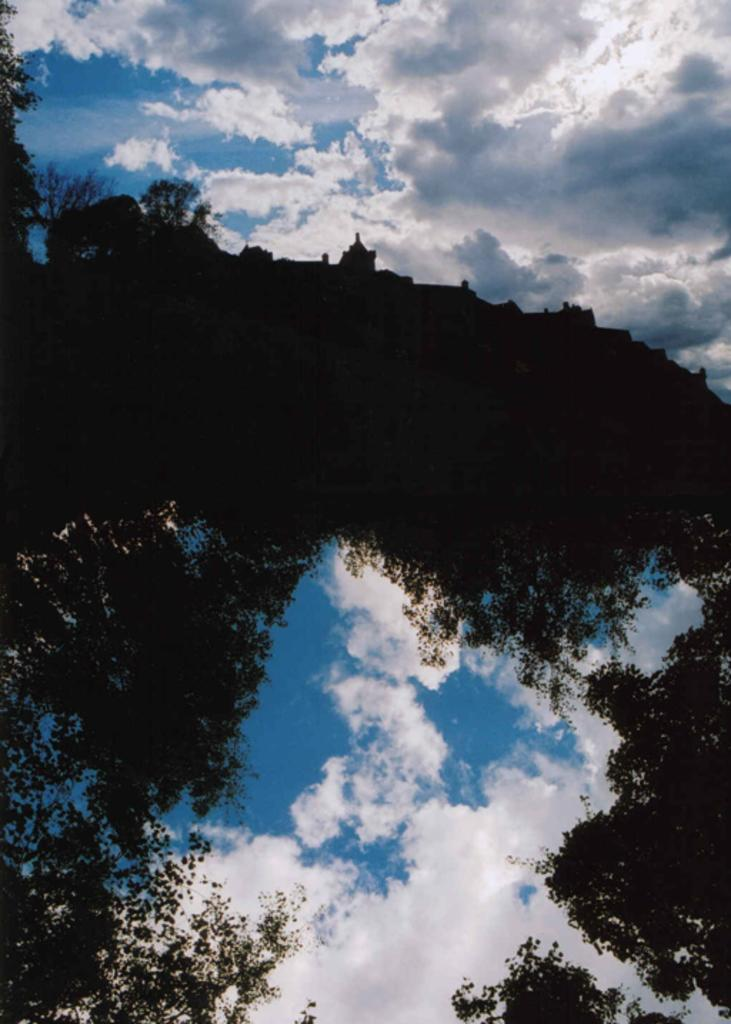What type of natural elements can be seen in the image? There are branches and clouds in the image. Can you describe the sky in the image? The sky in the image has clouds. How many fictional birds are flying among the clouds in the image? There are no fictional birds present in the image; it only features clouds and branches. 